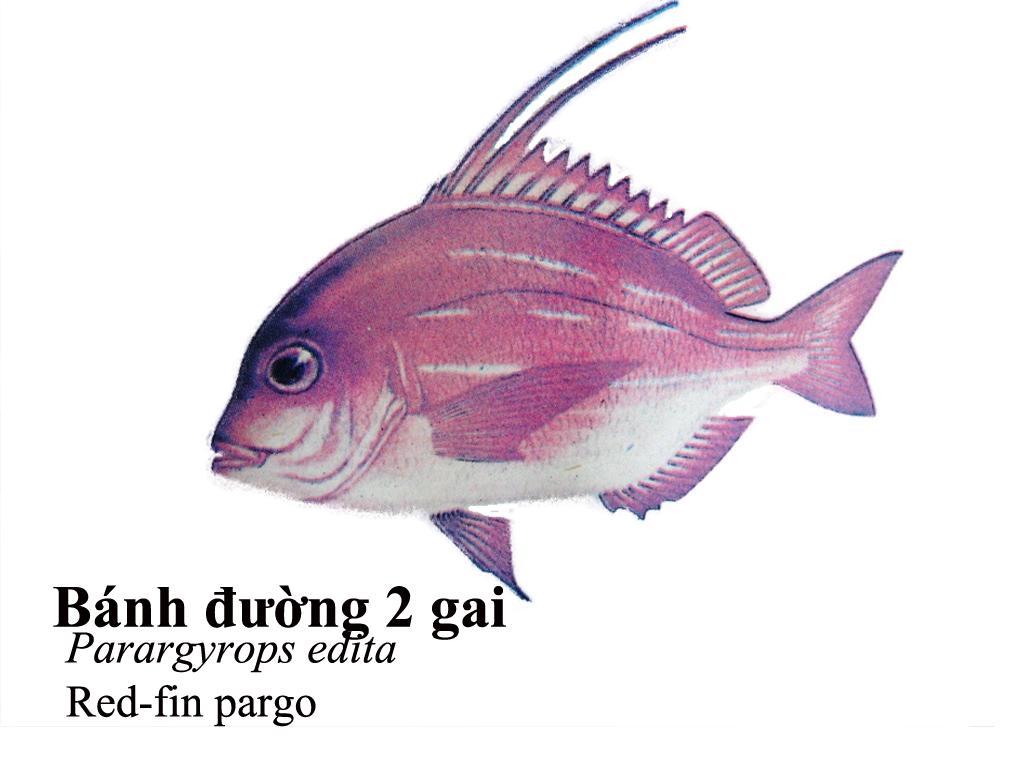Can you describe this image briefly? In this picture I can see a diagram of a fish, there are words and a number on the image. 